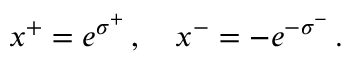Convert formula to latex. <formula><loc_0><loc_0><loc_500><loc_500>x ^ { + } = e ^ { \sigma ^ { + } } \, , \quad x ^ { - } = - e ^ { - \sigma ^ { - } } \, .</formula> 